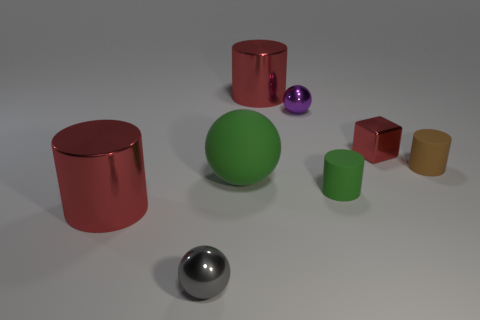Subtract all brown matte cylinders. How many cylinders are left? 3 Add 2 metallic things. How many objects exist? 10 Subtract all green balls. How many balls are left? 2 Subtract 3 cylinders. How many cylinders are left? 1 Subtract all green balls. How many red cylinders are left? 2 Subtract all spheres. How many objects are left? 5 Subtract all tiny purple metal blocks. Subtract all large things. How many objects are left? 5 Add 1 brown matte cylinders. How many brown matte cylinders are left? 2 Add 5 big cubes. How many big cubes exist? 5 Subtract 1 green spheres. How many objects are left? 7 